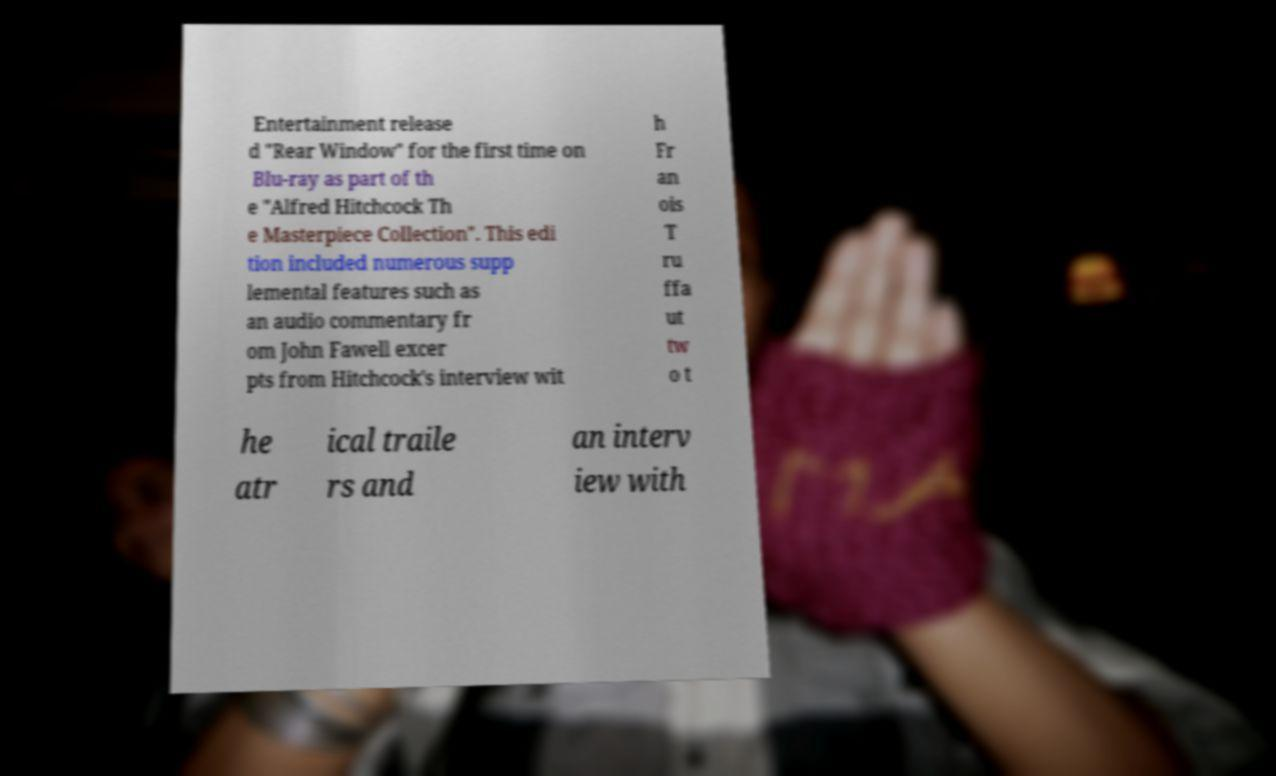There's text embedded in this image that I need extracted. Can you transcribe it verbatim? Entertainment release d "Rear Window" for the first time on Blu-ray as part of th e "Alfred Hitchcock Th e Masterpiece Collection". This edi tion included numerous supp lemental features such as an audio commentary fr om John Fawell excer pts from Hitchcock's interview wit h Fr an ois T ru ffa ut tw o t he atr ical traile rs and an interv iew with 